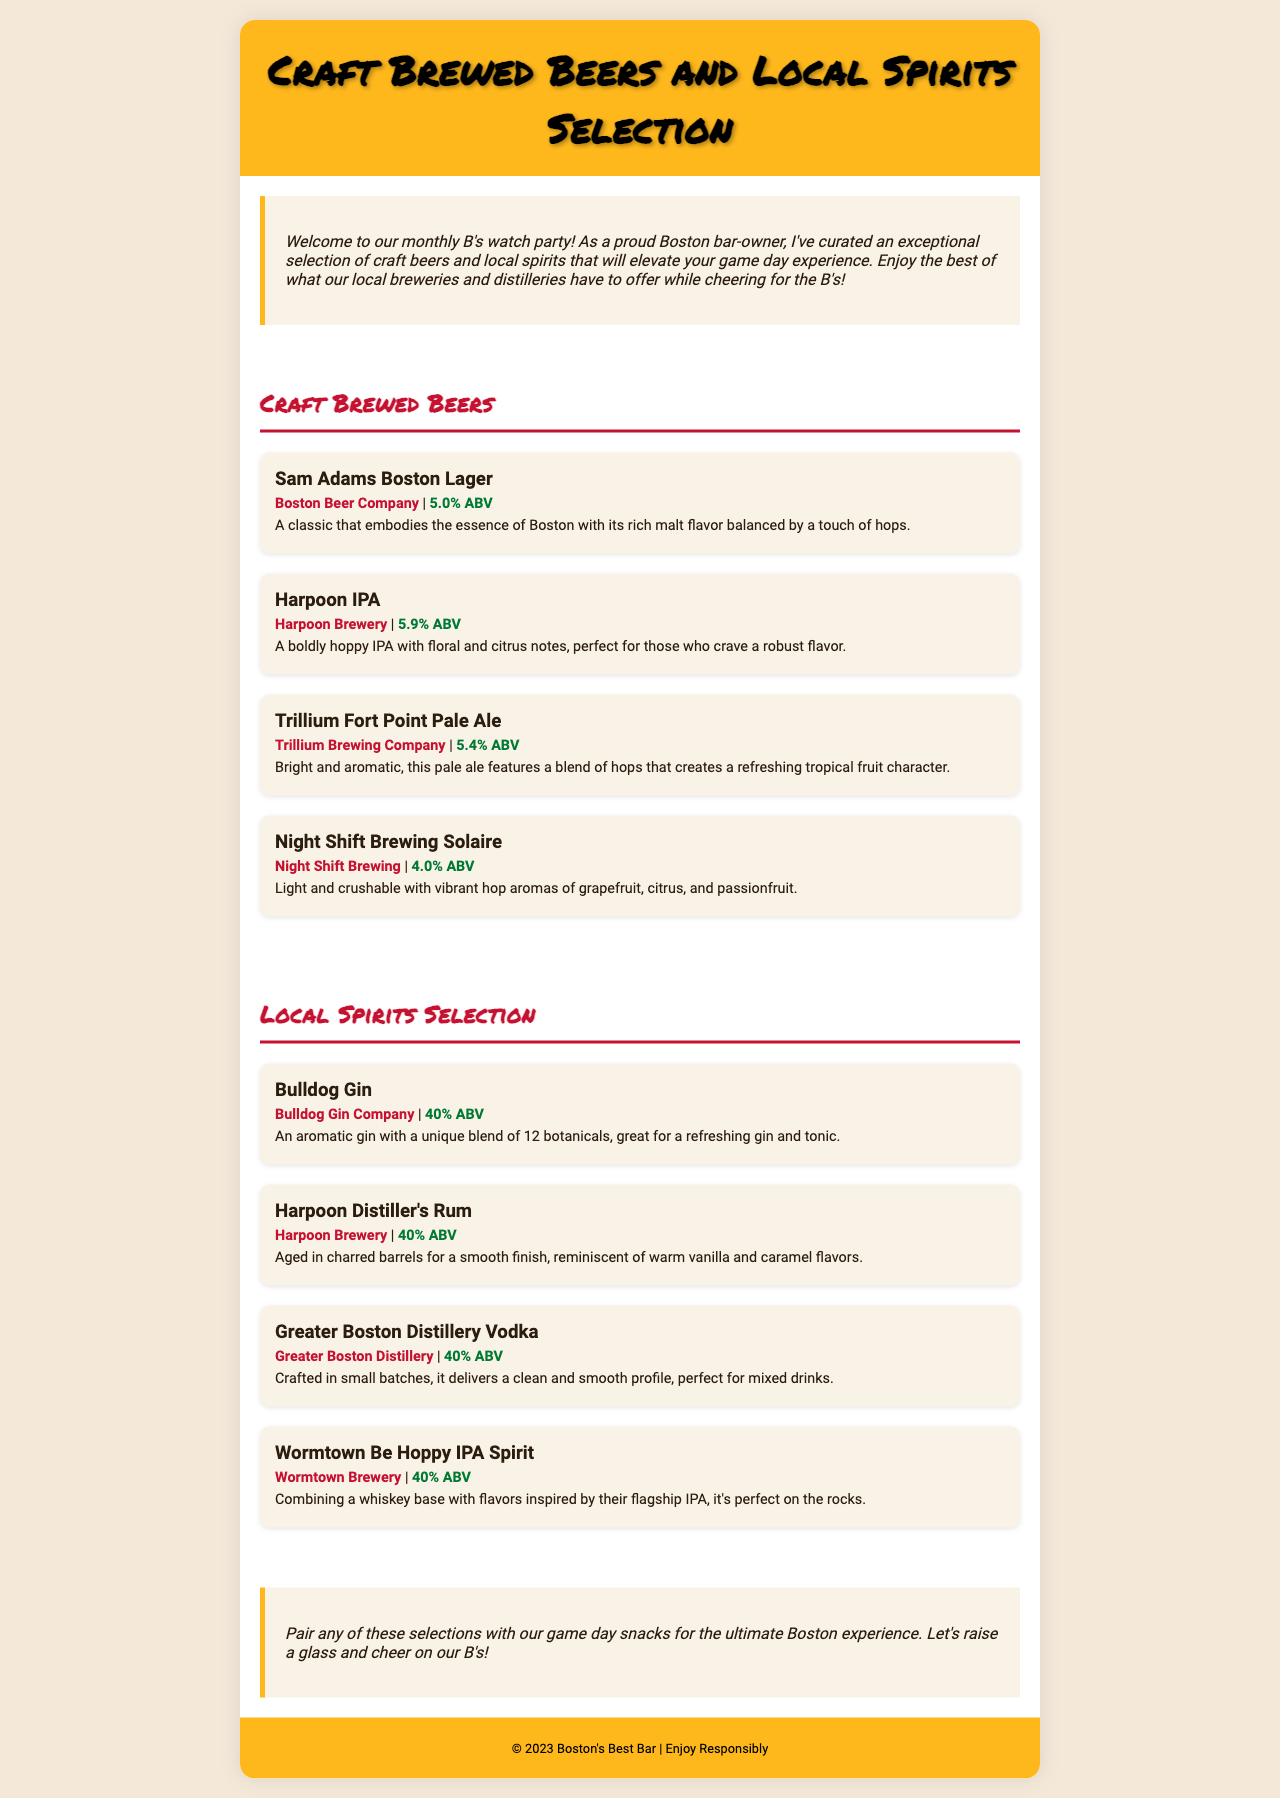What is the first craft brewed beer listed? The first craft brewed beer mentioned in the document is "Sam Adams Boston Lager."
Answer: Sam Adams Boston Lager What is the ABV of Harpoon IPA? The ABV (Alcohol by Volume) for Harpoon IPA is indicated as 5.9%.
Answer: 5.9% ABV Which distillery produces Bulldog Gin? The document states that Bulldog Gin is produced by Bulldog Gin Company.
Answer: Bulldog Gin Company How many local spirits are listed? There are four local spirits mentioned in the selection.
Answer: Four What flavor profile is described for the Harpoon Distiller's Rum? The flavor profile for Harpoon Distiller's Rum is described as reminiscent of warm vanilla and caramel.
Answer: warm vanilla and caramel What is the unique aspect of Wormtown Be Hoppy IPA Spirit? The Wormtown Be Hoppy IPA Spirit combines a whiskey base with flavors inspired by their flagship IPA.
Answer: whiskey base with flavors inspired by their flagship IPA Where is the watch party happening? The watch party is happening at Boston's Best Bar.
Answer: Boston's Best Bar What botanical count is mentioned for Bulldog Gin? The document indicates that Bulldog Gin has a unique blend of 12 botanicals.
Answer: 12 botanicals What type of beer is Trillium Fort Point Pale Ale described as? Trillium Fort Point Pale Ale is described as a pale ale.
Answer: pale ale 